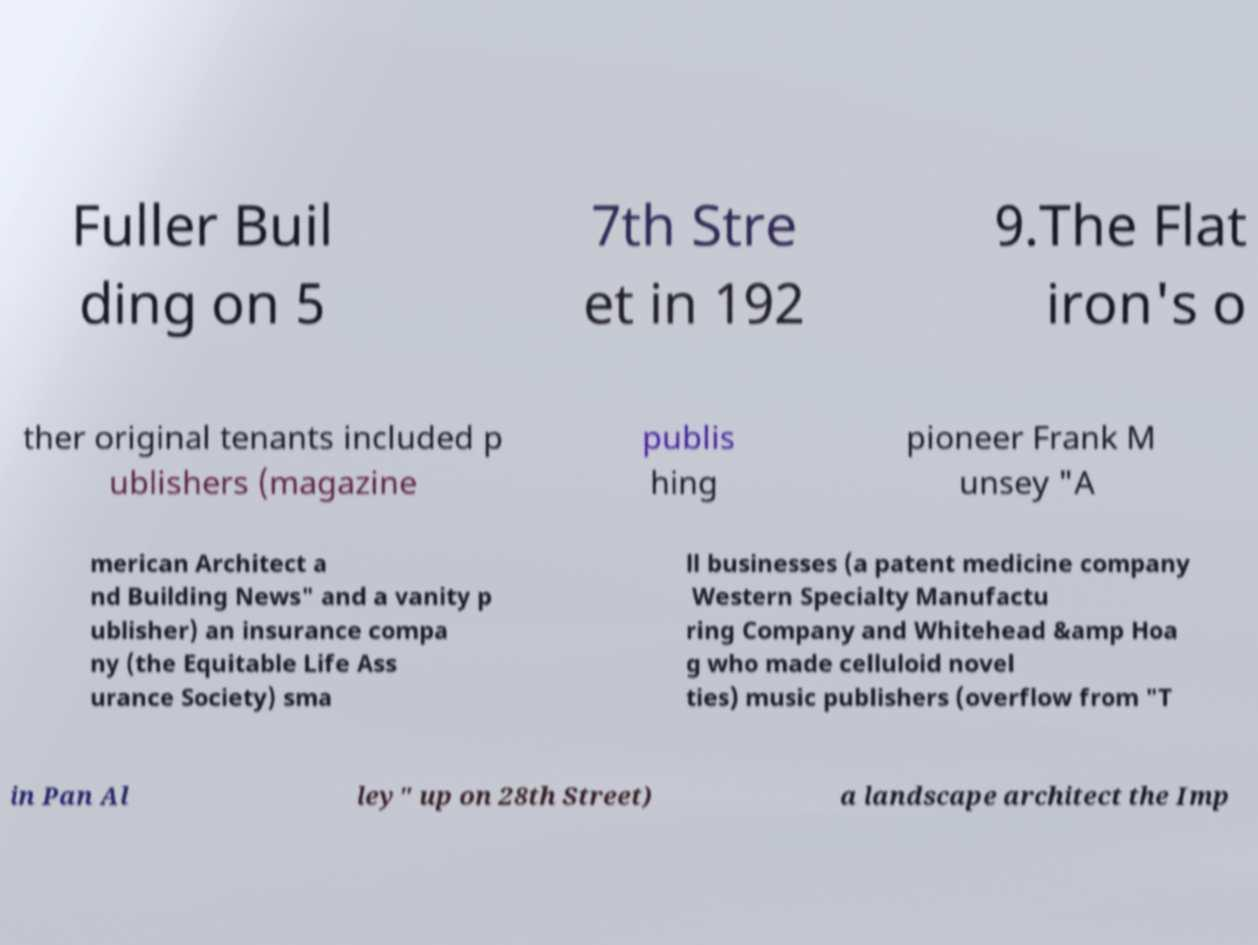Please read and relay the text visible in this image. What does it say? Fuller Buil ding on 5 7th Stre et in 192 9.The Flat iron's o ther original tenants included p ublishers (magazine publis hing pioneer Frank M unsey "A merican Architect a nd Building News" and a vanity p ublisher) an insurance compa ny (the Equitable Life Ass urance Society) sma ll businesses (a patent medicine company Western Specialty Manufactu ring Company and Whitehead &amp Hoa g who made celluloid novel ties) music publishers (overflow from "T in Pan Al ley" up on 28th Street) a landscape architect the Imp 